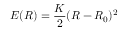Convert formula to latex. <formula><loc_0><loc_0><loc_500><loc_500>E ( R ) = \frac { K } { 2 } ( R - R _ { 0 } ) ^ { 2 }</formula> 